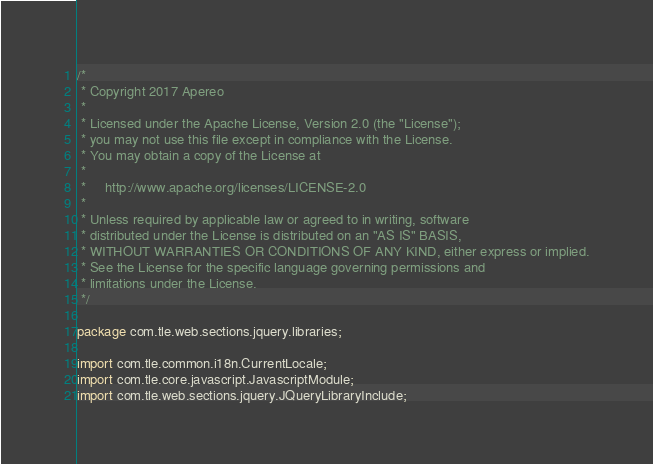<code> <loc_0><loc_0><loc_500><loc_500><_Java_>/*
 * Copyright 2017 Apereo
 *
 * Licensed under the Apache License, Version 2.0 (the "License");
 * you may not use this file except in compliance with the License.
 * You may obtain a copy of the License at
 *
 *     http://www.apache.org/licenses/LICENSE-2.0
 *
 * Unless required by applicable law or agreed to in writing, software
 * distributed under the License is distributed on an "AS IS" BASIS,
 * WITHOUT WARRANTIES OR CONDITIONS OF ANY KIND, either express or implied.
 * See the License for the specific language governing permissions and
 * limitations under the License.
 */

package com.tle.web.sections.jquery.libraries;

import com.tle.common.i18n.CurrentLocale;
import com.tle.core.javascript.JavascriptModule;
import com.tle.web.sections.jquery.JQueryLibraryInclude;</code> 